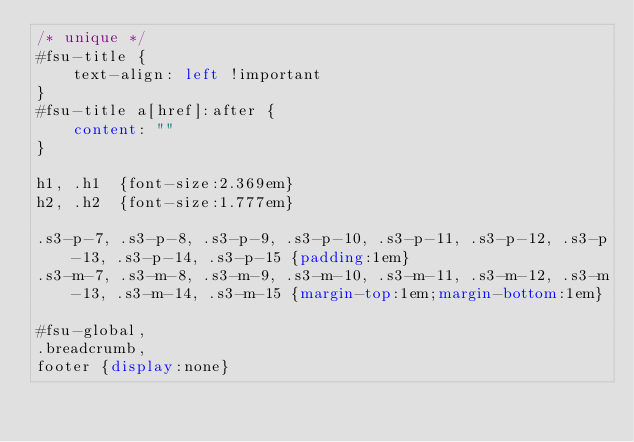Convert code to text. <code><loc_0><loc_0><loc_500><loc_500><_CSS_>/* unique */
#fsu-title {
	text-align: left !important
}
#fsu-title a[href]:after {
	content: ""
}

h1, .h1  {font-size:2.369em}
h2, .h2  {font-size:1.777em}

.s3-p-7, .s3-p-8, .s3-p-9, .s3-p-10, .s3-p-11, .s3-p-12, .s3-p-13, .s3-p-14, .s3-p-15 {padding:1em}
.s3-m-7, .s3-m-8, .s3-m-9, .s3-m-10, .s3-m-11, .s3-m-12, .s3-m-13, .s3-m-14, .s3-m-15 {margin-top:1em;margin-bottom:1em}

#fsu-global,
.breadcrumb,
footer {display:none}

</code> 